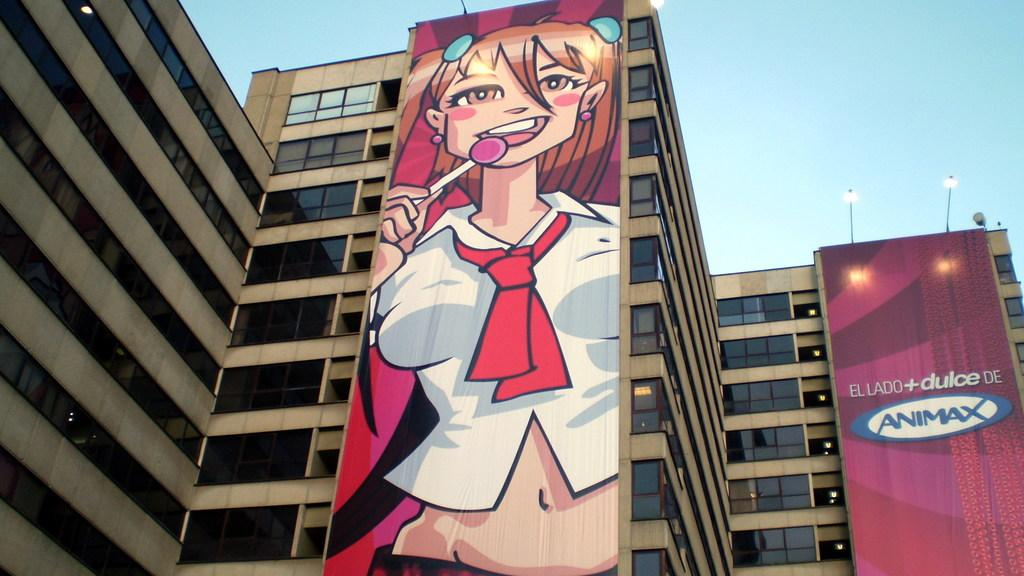What can be seen on the buildings in the image? There are two posters on the buildings. What other features are present on the buildings? There are windows on the buildings. What is visible at the top of the buildings? There are lights visible at the top of the buildings. What is visible in the background of the image? The sky is visible in the image. What type of record can be seen playing on the buildings in the image? There is no record present in the image; it features two posters on the buildings, windows, lights, and the sky. What effect does the mind have on the buildings in the image? There is no mention of the mind or any effects it might have on the buildings in the image. 